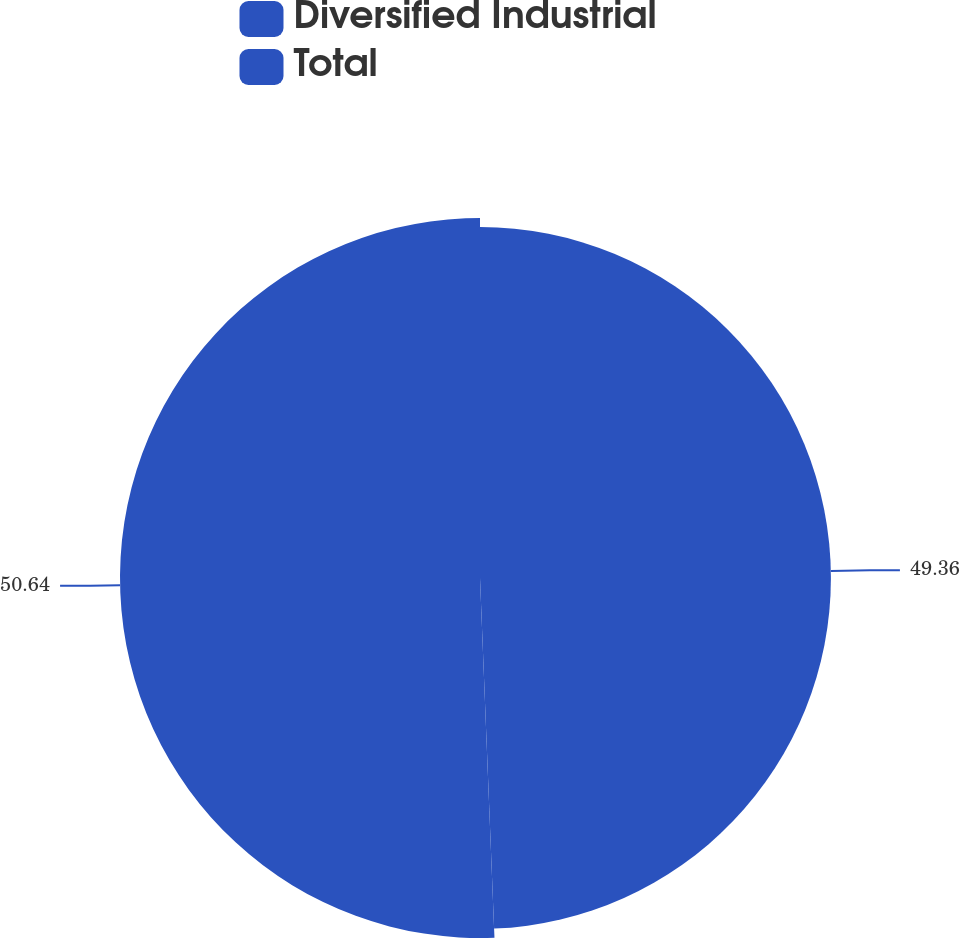Convert chart. <chart><loc_0><loc_0><loc_500><loc_500><pie_chart><fcel>Diversified Industrial<fcel>Total<nl><fcel>49.36%<fcel>50.64%<nl></chart> 